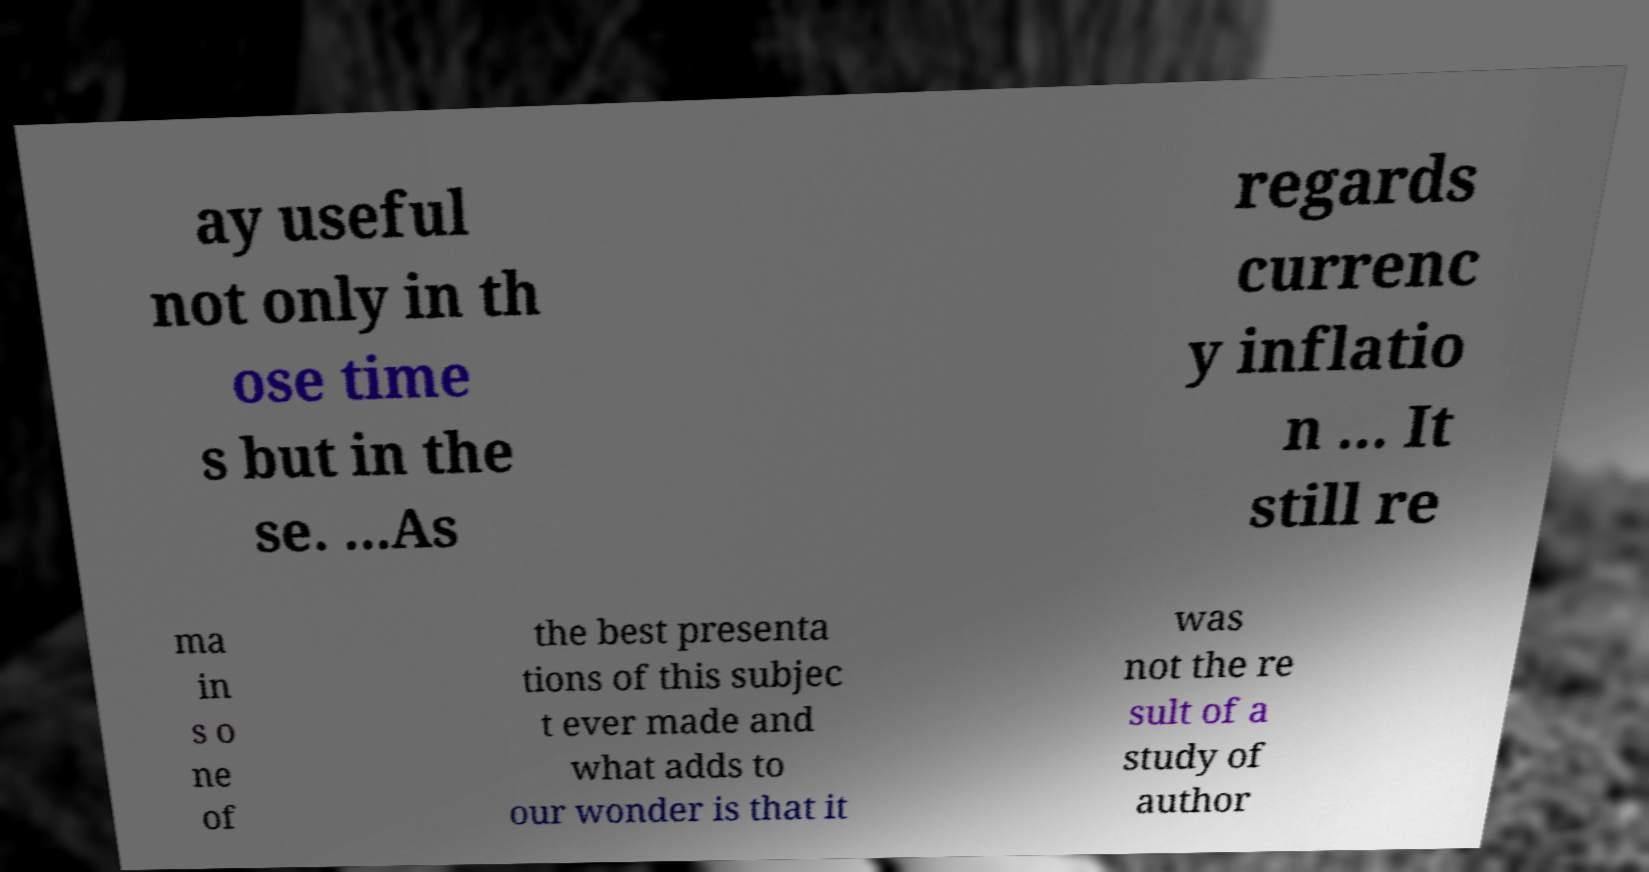There's text embedded in this image that I need extracted. Can you transcribe it verbatim? ay useful not only in th ose time s but in the se. ...As regards currenc y inflatio n ... It still re ma in s o ne of the best presenta tions of this subjec t ever made and what adds to our wonder is that it was not the re sult of a study of author 